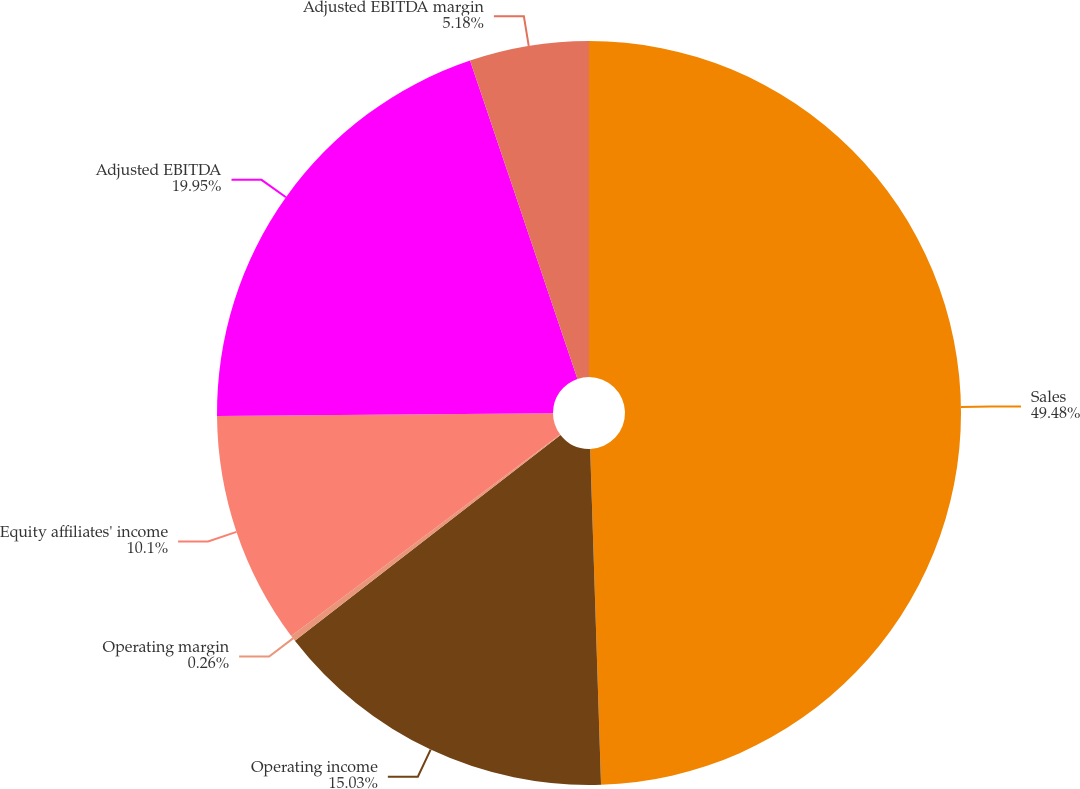<chart> <loc_0><loc_0><loc_500><loc_500><pie_chart><fcel>Sales<fcel>Operating income<fcel>Operating margin<fcel>Equity affiliates' income<fcel>Adjusted EBITDA<fcel>Adjusted EBITDA margin<nl><fcel>49.49%<fcel>15.03%<fcel>0.26%<fcel>10.1%<fcel>19.95%<fcel>5.18%<nl></chart> 